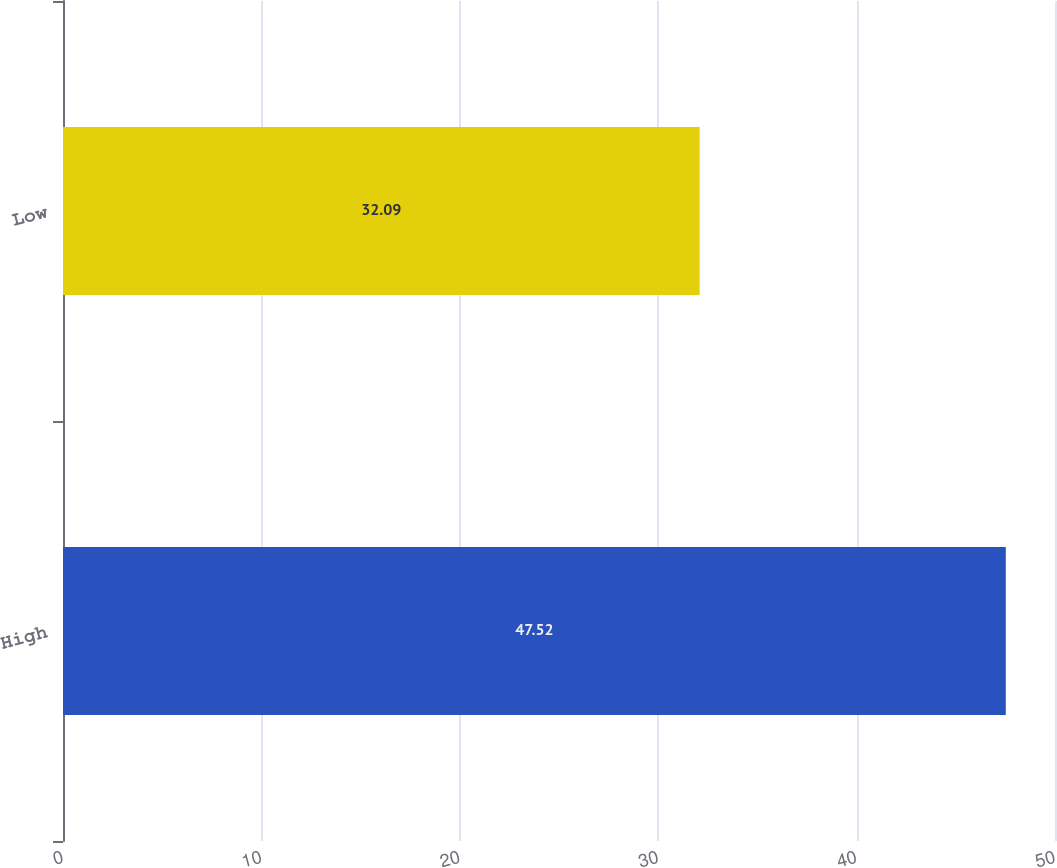<chart> <loc_0><loc_0><loc_500><loc_500><bar_chart><fcel>High<fcel>Low<nl><fcel>47.52<fcel>32.09<nl></chart> 